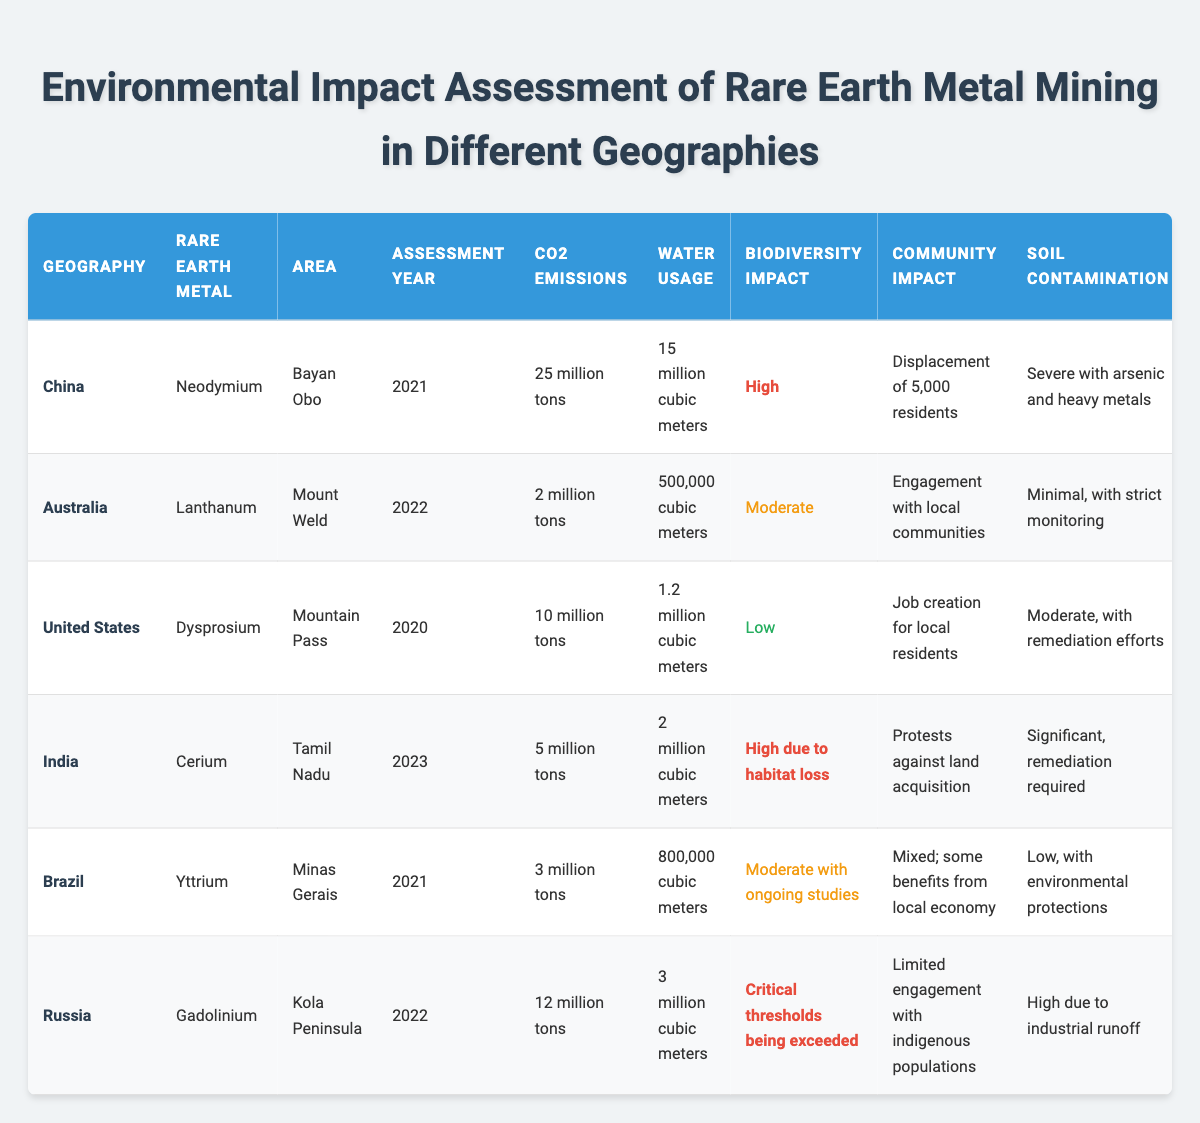What is the highest CO2 emission reported in the table? Referring to the CO2 emissions column, the highest value is 25 million tons, which belongs to China for Neodymium mining in Bayan Obo in 2021.
Answer: 25 million tons Which country has the lowest water usage for rare earth metal mining? Looking at the water usage column, Australia has the lowest usage at 500,000 cubic meters in Mount Weld for Lanthanum in 2022.
Answer: 500,000 cubic meters Is the biodiversity impact for Dysprosium in the United States low? The biodiversity impact for Dysprosium in the United States is marked as low in the table, confirming the statement is true.
Answer: Yes What year did India assess the environmental impacts of Cerium mining? The assessment year for Cerium mining in India is listed as 2023 in the table.
Answer: 2023 How many residents were displaced due to Neodymium mining in China? The community impact for Neodymium mining in China indicates the displacement of 5,000 residents.
Answer: 5,000 residents Calculate the total CO2 emissions from all listed countries. Summing up the CO2 emissions: 25 (China) + 2 (Australia) + 10 (United States) + 5 (India) + 3 (Brazil) + 12 (Russia) = 57 million tons.
Answer: 57 million tons Does Brazil have high soil contamination issues with its mining operations? The soil contamination level for Yttrium mining in Brazil is noted as low, indicating the statement is false.
Answer: No Which geographical location has a critical biodiversity impact? The biodiversity impact is noted as critical for Gadolinium mining in Russia, indicating it has exceeded critical thresholds.
Answer: Russia What's the difference in CO2 emissions between China and Australia? The difference in CO2 emissions is: 25 million tons (China) - 2 million tons (Australia) = 23 million tons.
Answer: 23 million tons Which regulatory framework is considered the strongest based on the assessment? Among the listed frameworks, Australia has a robust regulatory framework with regular audits, which is considered the strongest.
Answer: Australia 